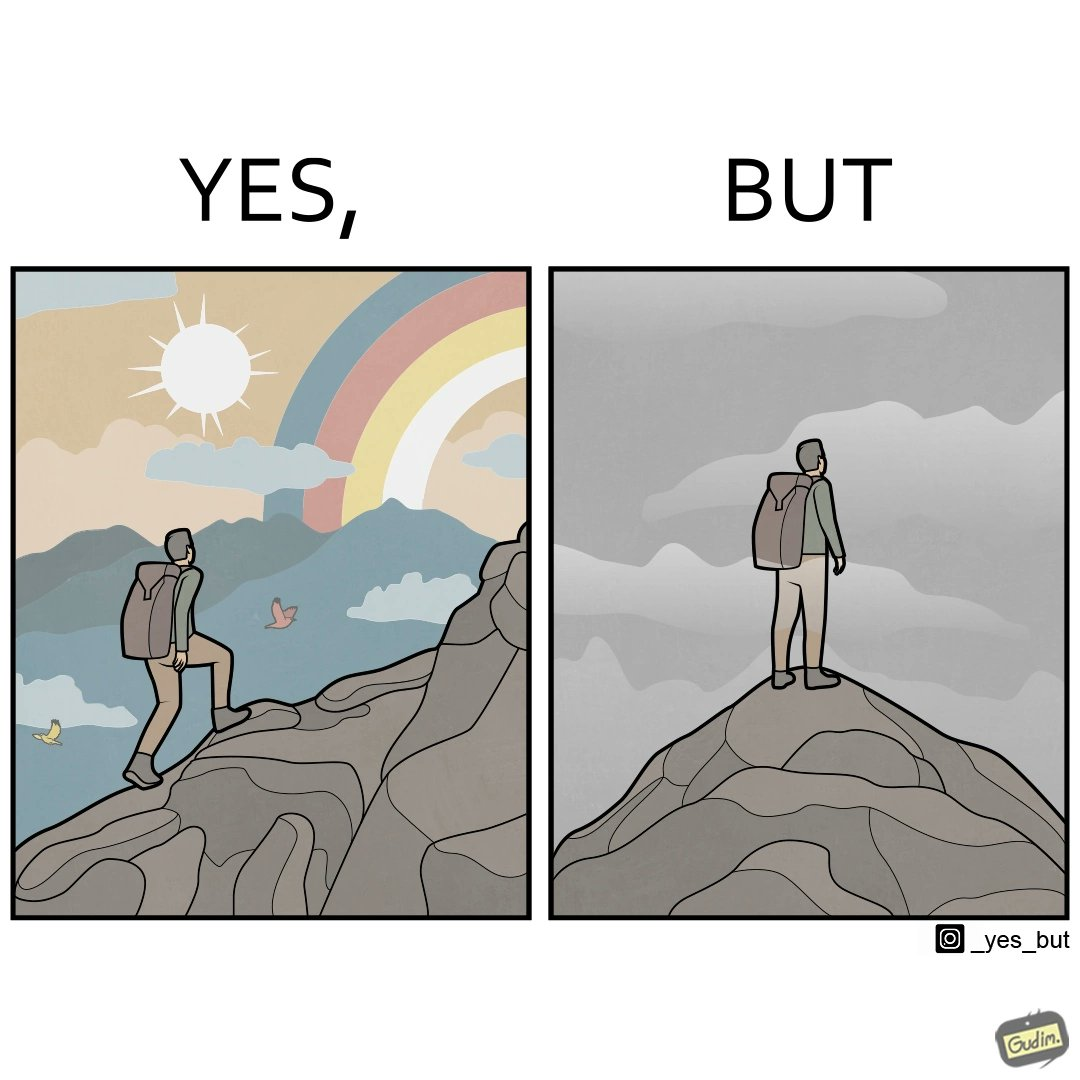What does this image depict? The image is ironic, because the mountaineer climbs up the mountain to view the world from the peak but due to so much cloud, at the top, nothing is visible whereas he was able to witness some awesome views while climbing up the mountain 